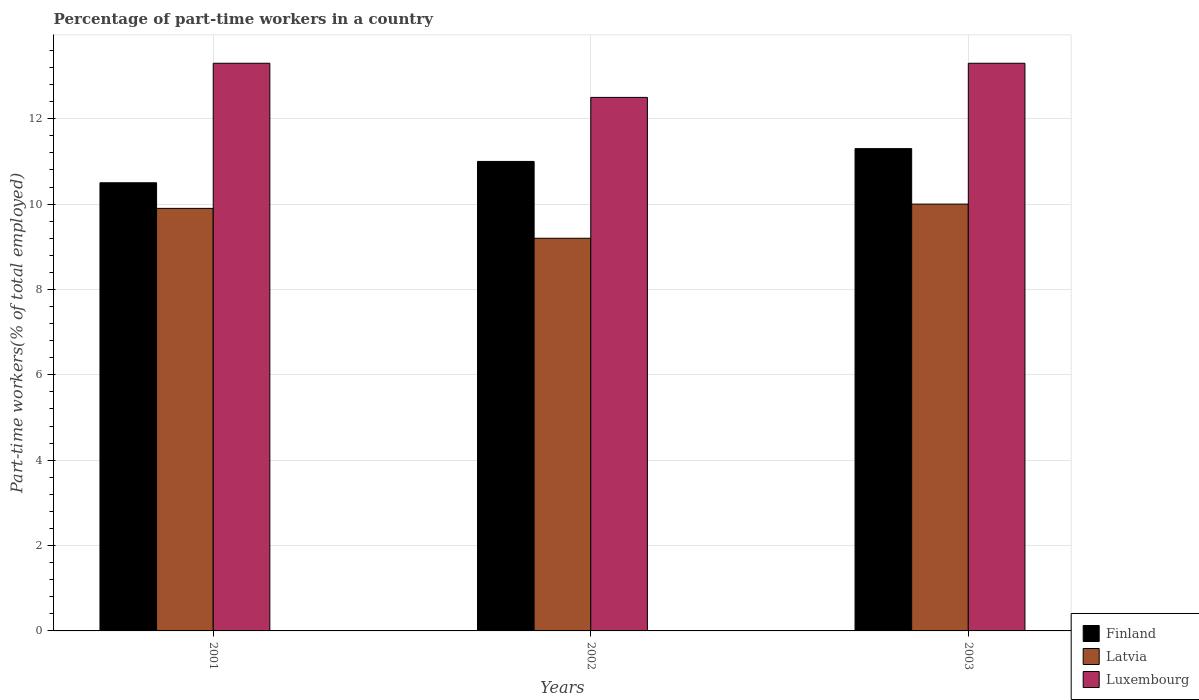How many groups of bars are there?
Offer a terse response. 3. Are the number of bars on each tick of the X-axis equal?
Offer a terse response. Yes. How many bars are there on the 3rd tick from the left?
Offer a terse response. 3. How many bars are there on the 2nd tick from the right?
Your answer should be very brief. 3. What is the label of the 1st group of bars from the left?
Offer a terse response. 2001. What is the percentage of part-time workers in Finland in 2003?
Ensure brevity in your answer.  11.3. Across all years, what is the maximum percentage of part-time workers in Finland?
Your answer should be very brief. 11.3. Across all years, what is the minimum percentage of part-time workers in Luxembourg?
Provide a succinct answer. 12.5. What is the total percentage of part-time workers in Luxembourg in the graph?
Your answer should be very brief. 39.1. What is the difference between the percentage of part-time workers in Latvia in 2001 and that in 2003?
Provide a short and direct response. -0.1. What is the difference between the percentage of part-time workers in Finland in 2001 and the percentage of part-time workers in Latvia in 2002?
Your answer should be very brief. 1.3. What is the average percentage of part-time workers in Finland per year?
Offer a terse response. 10.93. In the year 2001, what is the difference between the percentage of part-time workers in Luxembourg and percentage of part-time workers in Latvia?
Your response must be concise. 3.4. In how many years, is the percentage of part-time workers in Latvia greater than 0.4 %?
Keep it short and to the point. 3. What is the ratio of the percentage of part-time workers in Finland in 2002 to that in 2003?
Your answer should be compact. 0.97. Is the difference between the percentage of part-time workers in Luxembourg in 2002 and 2003 greater than the difference between the percentage of part-time workers in Latvia in 2002 and 2003?
Make the answer very short. No. What is the difference between the highest and the second highest percentage of part-time workers in Luxembourg?
Provide a succinct answer. 0. What is the difference between the highest and the lowest percentage of part-time workers in Finland?
Keep it short and to the point. 0.8. In how many years, is the percentage of part-time workers in Finland greater than the average percentage of part-time workers in Finland taken over all years?
Ensure brevity in your answer.  2. Is the sum of the percentage of part-time workers in Finland in 2001 and 2003 greater than the maximum percentage of part-time workers in Luxembourg across all years?
Your response must be concise. Yes. What does the 2nd bar from the left in 2001 represents?
Give a very brief answer. Latvia. What does the 1st bar from the right in 2002 represents?
Offer a terse response. Luxembourg. Is it the case that in every year, the sum of the percentage of part-time workers in Finland and percentage of part-time workers in Latvia is greater than the percentage of part-time workers in Luxembourg?
Ensure brevity in your answer.  Yes. How many bars are there?
Provide a short and direct response. 9. Are all the bars in the graph horizontal?
Offer a very short reply. No. How many years are there in the graph?
Offer a terse response. 3. What is the difference between two consecutive major ticks on the Y-axis?
Offer a terse response. 2. Does the graph contain any zero values?
Provide a short and direct response. No. How many legend labels are there?
Provide a succinct answer. 3. What is the title of the graph?
Offer a terse response. Percentage of part-time workers in a country. Does "New Caledonia" appear as one of the legend labels in the graph?
Make the answer very short. No. What is the label or title of the X-axis?
Offer a very short reply. Years. What is the label or title of the Y-axis?
Provide a succinct answer. Part-time workers(% of total employed). What is the Part-time workers(% of total employed) in Latvia in 2001?
Give a very brief answer. 9.9. What is the Part-time workers(% of total employed) of Luxembourg in 2001?
Provide a succinct answer. 13.3. What is the Part-time workers(% of total employed) in Finland in 2002?
Ensure brevity in your answer.  11. What is the Part-time workers(% of total employed) of Latvia in 2002?
Ensure brevity in your answer.  9.2. What is the Part-time workers(% of total employed) of Finland in 2003?
Offer a terse response. 11.3. What is the Part-time workers(% of total employed) of Latvia in 2003?
Ensure brevity in your answer.  10. What is the Part-time workers(% of total employed) of Luxembourg in 2003?
Provide a succinct answer. 13.3. Across all years, what is the maximum Part-time workers(% of total employed) of Finland?
Provide a short and direct response. 11.3. Across all years, what is the maximum Part-time workers(% of total employed) in Latvia?
Your response must be concise. 10. Across all years, what is the maximum Part-time workers(% of total employed) of Luxembourg?
Provide a short and direct response. 13.3. Across all years, what is the minimum Part-time workers(% of total employed) in Finland?
Ensure brevity in your answer.  10.5. Across all years, what is the minimum Part-time workers(% of total employed) in Latvia?
Provide a short and direct response. 9.2. Across all years, what is the minimum Part-time workers(% of total employed) in Luxembourg?
Keep it short and to the point. 12.5. What is the total Part-time workers(% of total employed) in Finland in the graph?
Provide a succinct answer. 32.8. What is the total Part-time workers(% of total employed) in Latvia in the graph?
Offer a very short reply. 29.1. What is the total Part-time workers(% of total employed) in Luxembourg in the graph?
Your answer should be compact. 39.1. What is the difference between the Part-time workers(% of total employed) of Latvia in 2001 and that in 2002?
Your response must be concise. 0.7. What is the difference between the Part-time workers(% of total employed) of Luxembourg in 2001 and that in 2002?
Provide a short and direct response. 0.8. What is the difference between the Part-time workers(% of total employed) of Latvia in 2001 and that in 2003?
Keep it short and to the point. -0.1. What is the difference between the Part-time workers(% of total employed) of Luxembourg in 2001 and that in 2003?
Provide a short and direct response. 0. What is the difference between the Part-time workers(% of total employed) in Latvia in 2002 and that in 2003?
Give a very brief answer. -0.8. What is the difference between the Part-time workers(% of total employed) in Luxembourg in 2002 and that in 2003?
Provide a succinct answer. -0.8. What is the difference between the Part-time workers(% of total employed) in Finland in 2001 and the Part-time workers(% of total employed) in Latvia in 2002?
Provide a succinct answer. 1.3. What is the difference between the Part-time workers(% of total employed) in Finland in 2001 and the Part-time workers(% of total employed) in Luxembourg in 2002?
Offer a terse response. -2. What is the difference between the Part-time workers(% of total employed) in Finland in 2002 and the Part-time workers(% of total employed) in Latvia in 2003?
Offer a terse response. 1. What is the difference between the Part-time workers(% of total employed) in Finland in 2002 and the Part-time workers(% of total employed) in Luxembourg in 2003?
Your answer should be compact. -2.3. What is the average Part-time workers(% of total employed) of Finland per year?
Provide a short and direct response. 10.93. What is the average Part-time workers(% of total employed) in Latvia per year?
Your answer should be compact. 9.7. What is the average Part-time workers(% of total employed) of Luxembourg per year?
Ensure brevity in your answer.  13.03. In the year 2001, what is the difference between the Part-time workers(% of total employed) of Latvia and Part-time workers(% of total employed) of Luxembourg?
Provide a short and direct response. -3.4. In the year 2002, what is the difference between the Part-time workers(% of total employed) in Finland and Part-time workers(% of total employed) in Latvia?
Keep it short and to the point. 1.8. In the year 2002, what is the difference between the Part-time workers(% of total employed) of Finland and Part-time workers(% of total employed) of Luxembourg?
Your answer should be compact. -1.5. In the year 2002, what is the difference between the Part-time workers(% of total employed) in Latvia and Part-time workers(% of total employed) in Luxembourg?
Ensure brevity in your answer.  -3.3. In the year 2003, what is the difference between the Part-time workers(% of total employed) in Finland and Part-time workers(% of total employed) in Latvia?
Make the answer very short. 1.3. In the year 2003, what is the difference between the Part-time workers(% of total employed) in Finland and Part-time workers(% of total employed) in Luxembourg?
Your response must be concise. -2. What is the ratio of the Part-time workers(% of total employed) of Finland in 2001 to that in 2002?
Ensure brevity in your answer.  0.95. What is the ratio of the Part-time workers(% of total employed) of Latvia in 2001 to that in 2002?
Your answer should be compact. 1.08. What is the ratio of the Part-time workers(% of total employed) of Luxembourg in 2001 to that in 2002?
Your response must be concise. 1.06. What is the ratio of the Part-time workers(% of total employed) of Finland in 2001 to that in 2003?
Provide a short and direct response. 0.93. What is the ratio of the Part-time workers(% of total employed) of Latvia in 2001 to that in 2003?
Give a very brief answer. 0.99. What is the ratio of the Part-time workers(% of total employed) of Finland in 2002 to that in 2003?
Give a very brief answer. 0.97. What is the ratio of the Part-time workers(% of total employed) of Latvia in 2002 to that in 2003?
Ensure brevity in your answer.  0.92. What is the ratio of the Part-time workers(% of total employed) of Luxembourg in 2002 to that in 2003?
Ensure brevity in your answer.  0.94. What is the difference between the highest and the second highest Part-time workers(% of total employed) of Latvia?
Keep it short and to the point. 0.1. What is the difference between the highest and the second highest Part-time workers(% of total employed) in Luxembourg?
Offer a very short reply. 0. What is the difference between the highest and the lowest Part-time workers(% of total employed) in Finland?
Provide a succinct answer. 0.8. 